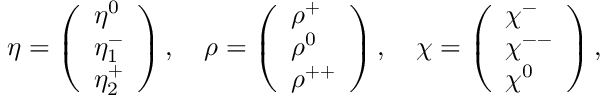Convert formula to latex. <formula><loc_0><loc_0><loc_500><loc_500>\eta = \left ( \begin{array} { l } { { \eta ^ { 0 } } } \\ { { \eta _ { 1 } ^ { - } } } \\ { { \eta _ { 2 } ^ { + } } } \end{array} \right ) , \quad \rho = \left ( \begin{array} { l } { { \rho ^ { + } } } \\ { { \rho ^ { 0 } } } \\ { { \rho ^ { + + } } } \end{array} \right ) , \quad \chi = \left ( \begin{array} { l } { { \chi ^ { - } } } \\ { { \chi ^ { - - } } } \\ { { \chi ^ { 0 } } } \end{array} \right ) ,</formula> 